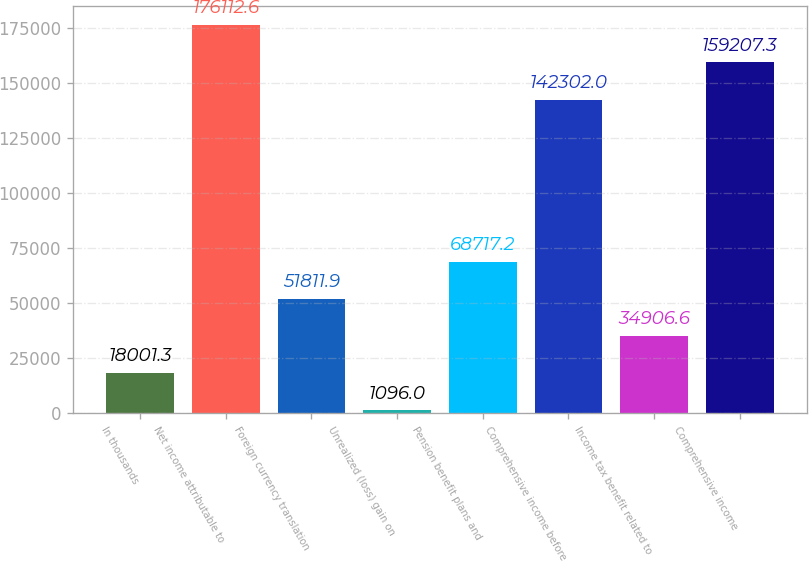Convert chart to OTSL. <chart><loc_0><loc_0><loc_500><loc_500><bar_chart><fcel>In thousands<fcel>Net income attributable to<fcel>Foreign currency translation<fcel>Unrealized (loss) gain on<fcel>Pension benefit plans and<fcel>Comprehensive income before<fcel>Income tax benefit related to<fcel>Comprehensive income<nl><fcel>18001.3<fcel>176113<fcel>51811.9<fcel>1096<fcel>68717.2<fcel>142302<fcel>34906.6<fcel>159207<nl></chart> 